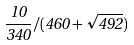Convert formula to latex. <formula><loc_0><loc_0><loc_500><loc_500>\frac { 1 0 } { 3 4 0 } / ( 4 6 0 + \sqrt { 4 9 2 } )</formula> 